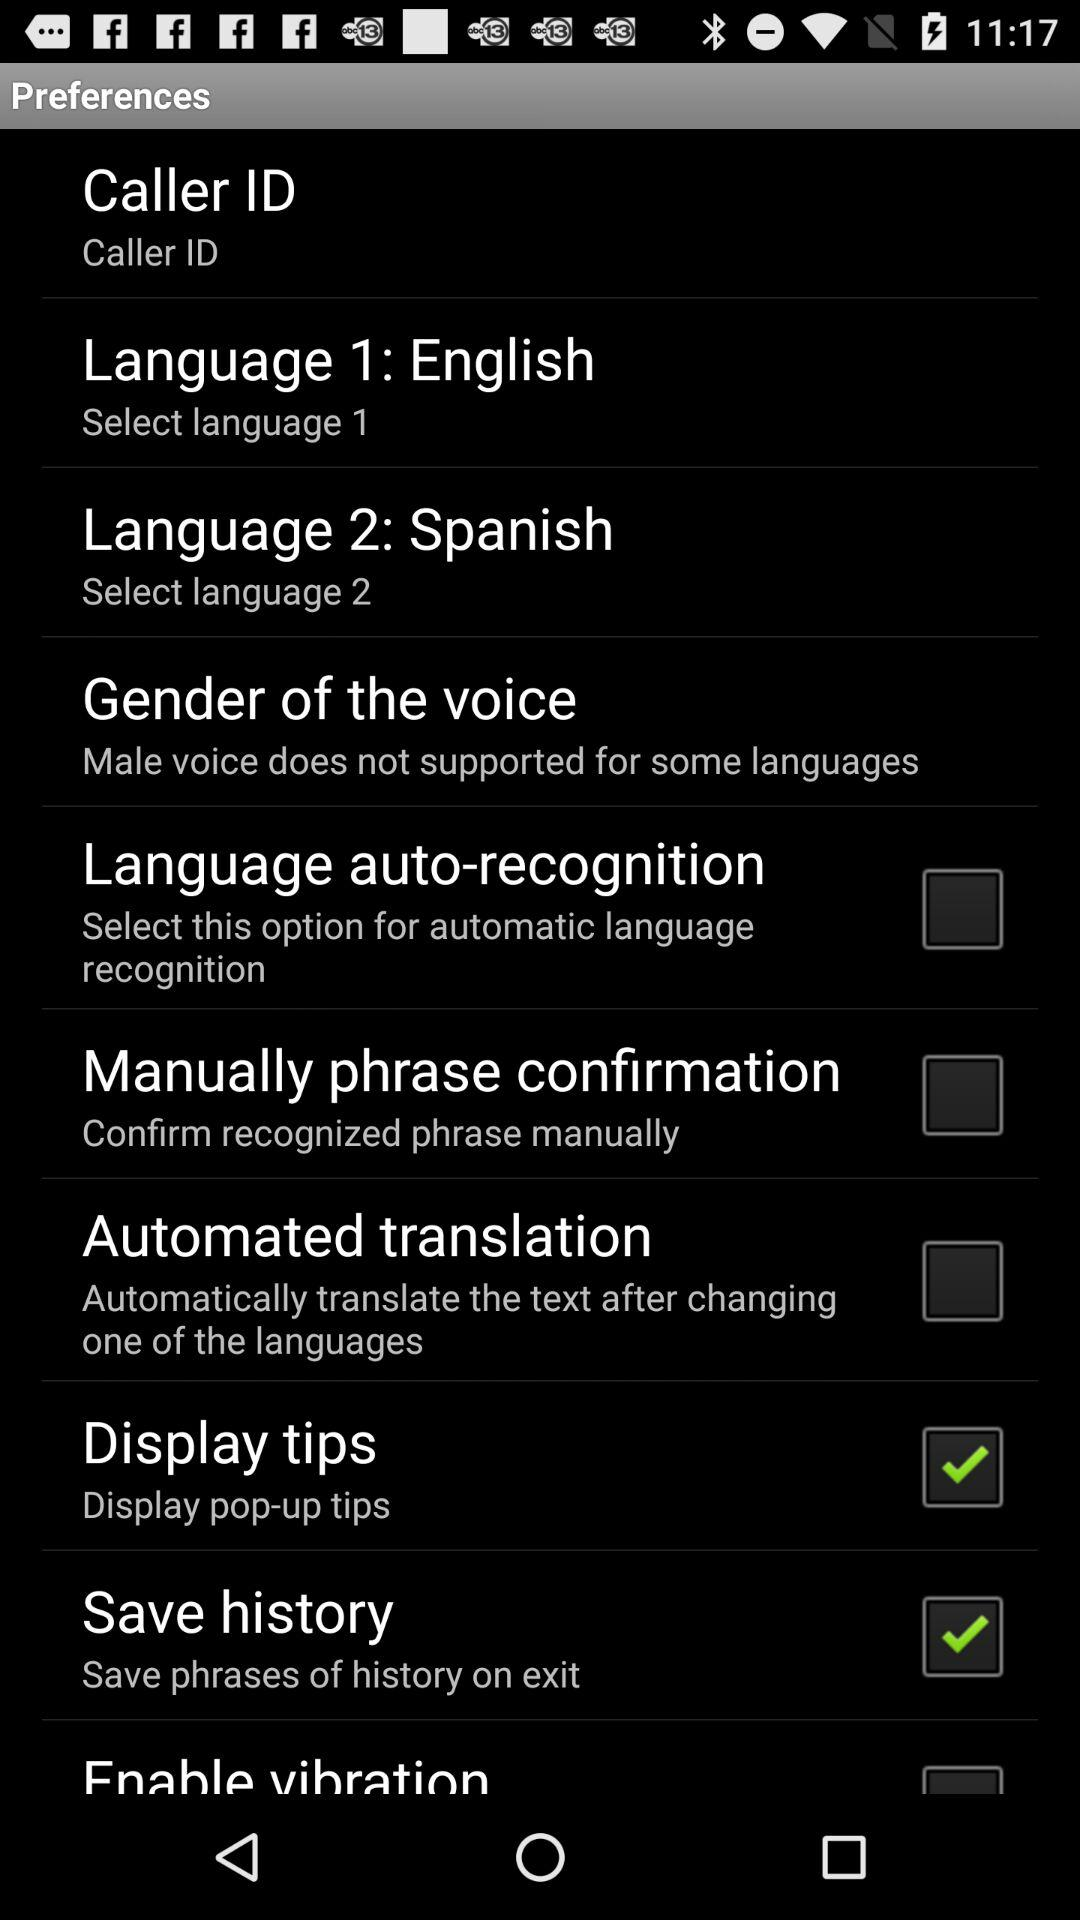Which language is set as "Language 2"? The language that is set as "Language 2" is Spanish. 